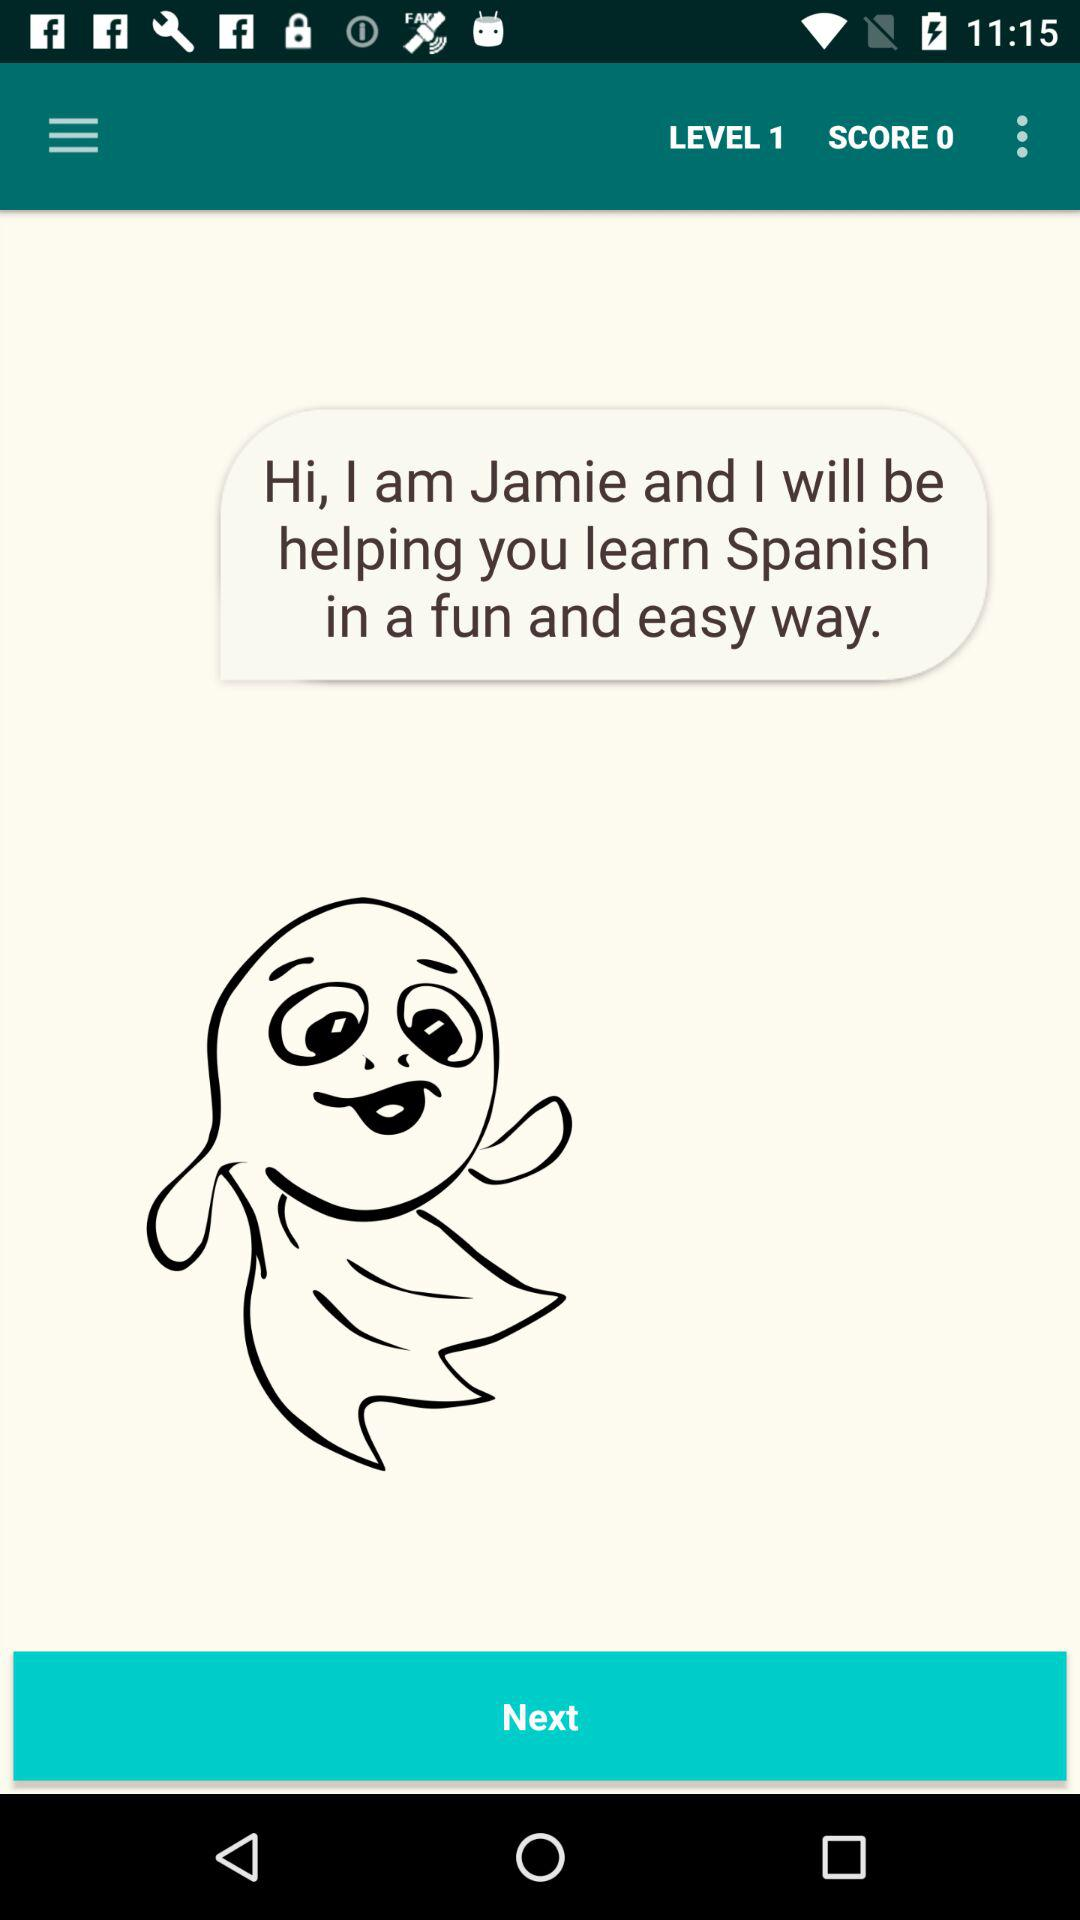At what level is shown? The shown label is 1. 